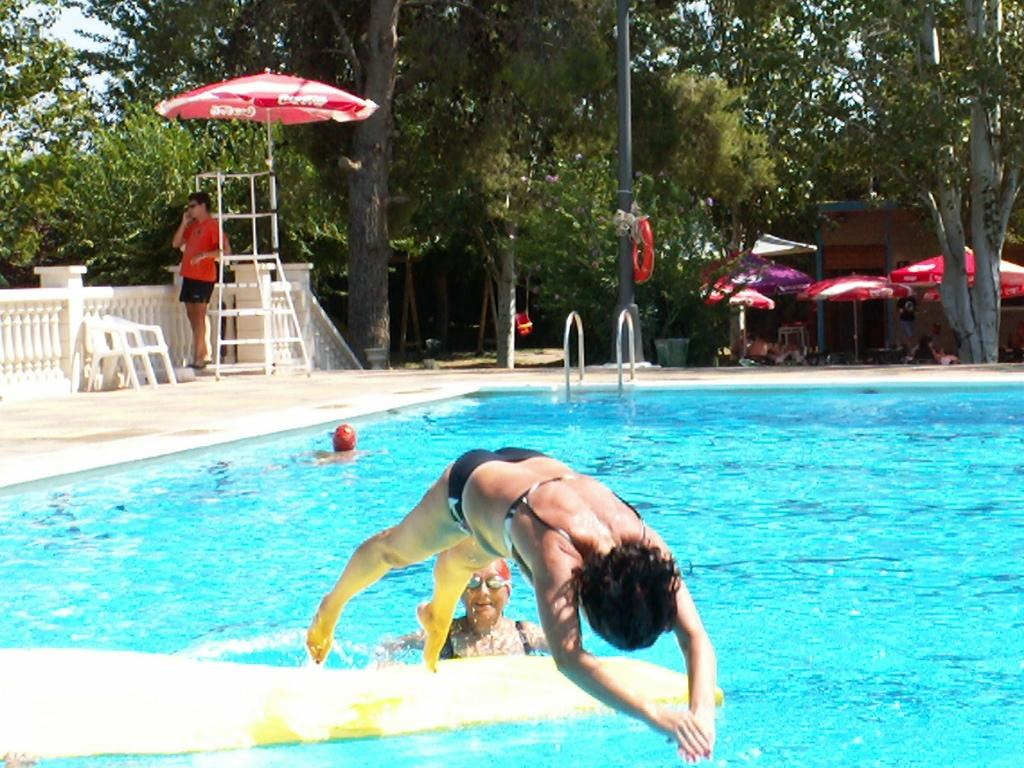What can be seen in the sky in the image? The sky is visible in the image. What type of vegetation is present in the image? There are trees in the image. What items are used for shade in the image? There are parasols in the image. What is used for cooking in the image? There are grills in the image. What type of furniture is present in the image? There are chairs in the image. What type of recreational feature is present in the image? There is a swimming pool in the image. Are there any people in the image? Yes, there are persons in the image. What type of crow is perched on the wrist of one of the persons in the image? There is no crow present in the image, nor is there any indication of a person with a crow on their wrist. What type of necklace is being worn by the person in the image? There is no necklace visible in the image. 